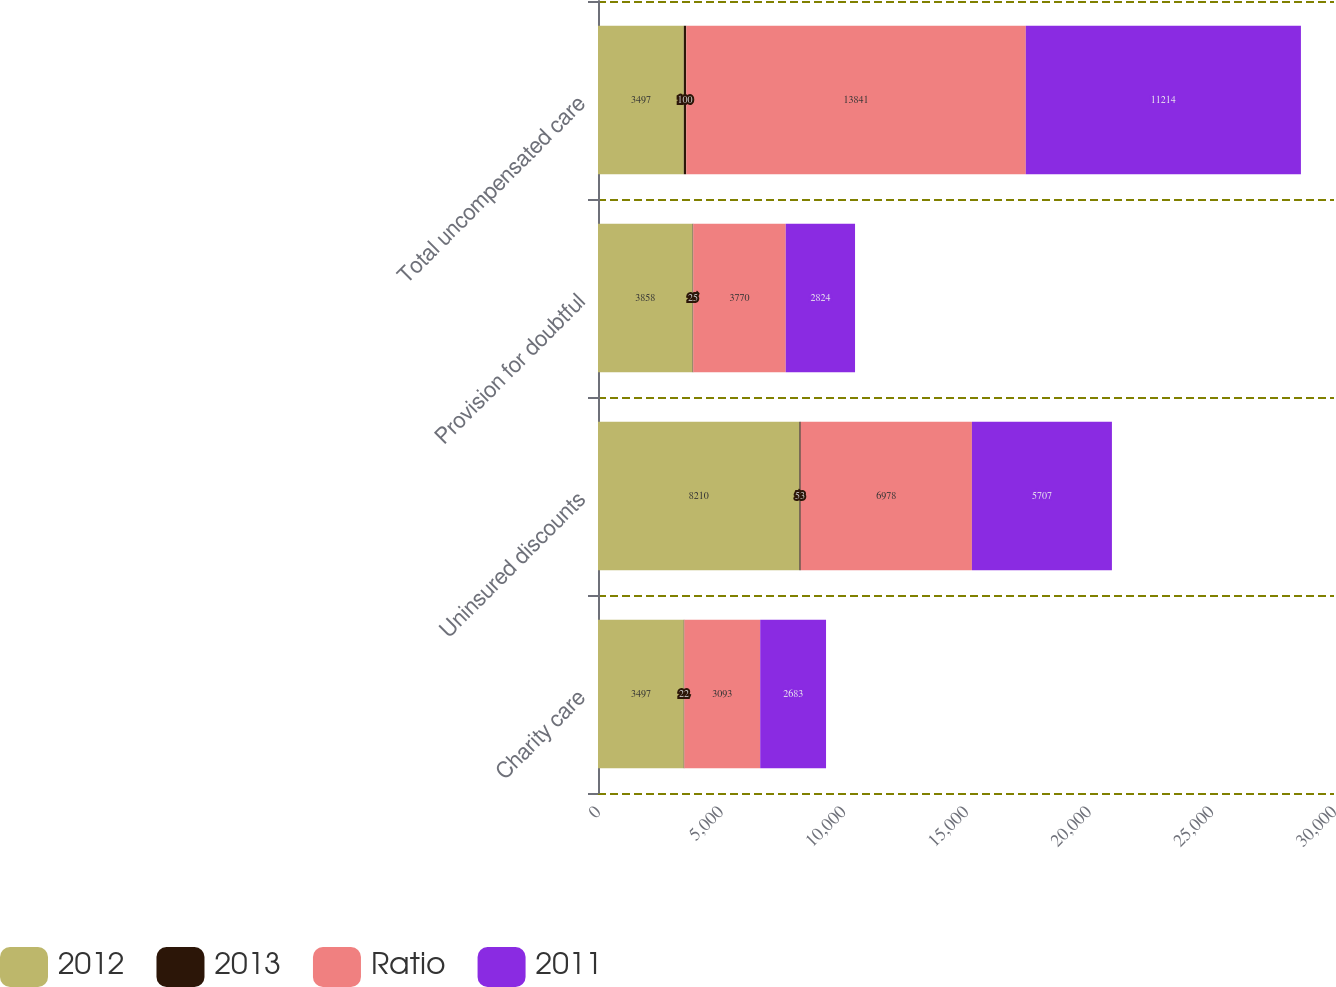Convert chart to OTSL. <chart><loc_0><loc_0><loc_500><loc_500><stacked_bar_chart><ecel><fcel>Charity care<fcel>Uninsured discounts<fcel>Provision for doubtful<fcel>Total uncompensated care<nl><fcel>2012<fcel>3497<fcel>8210<fcel>3858<fcel>3497<nl><fcel>2013<fcel>22<fcel>53<fcel>25<fcel>100<nl><fcel>Ratio<fcel>3093<fcel>6978<fcel>3770<fcel>13841<nl><fcel>2011<fcel>2683<fcel>5707<fcel>2824<fcel>11214<nl></chart> 